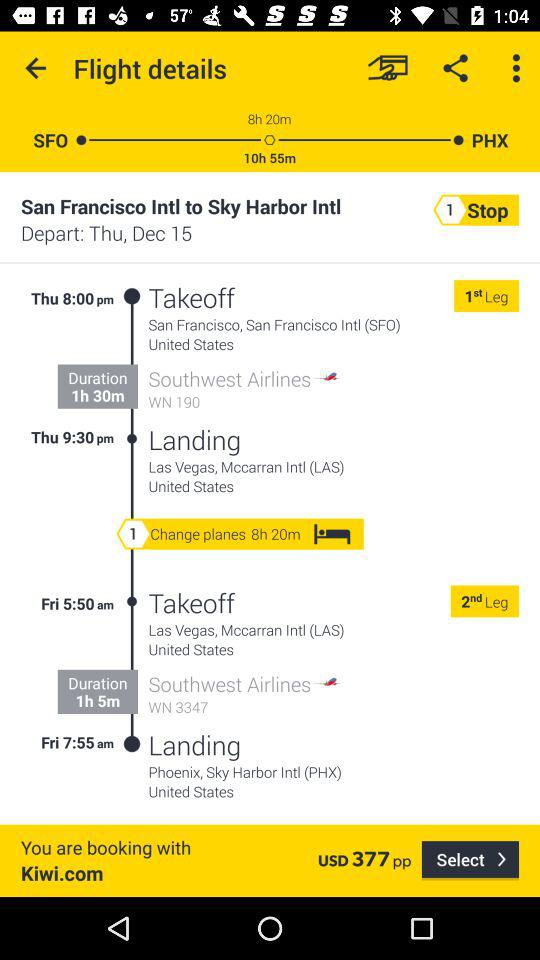When will the flight arrive at its destination? The flight will arrive at its destination on Friday at 7:55 a.m. 